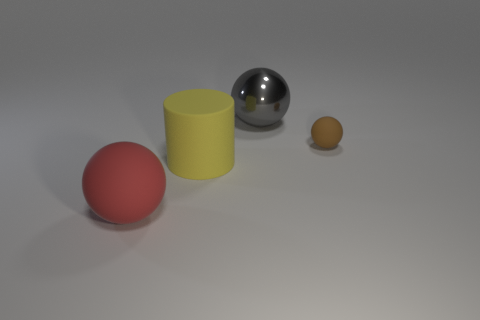Subtract all large spheres. How many spheres are left? 1 Add 3 yellow rubber cylinders. How many objects exist? 7 Subtract all yellow balls. Subtract all red cylinders. How many balls are left? 3 Subtract all small blue things. Subtract all rubber spheres. How many objects are left? 2 Add 1 large yellow matte cylinders. How many large yellow matte cylinders are left? 2 Add 2 big brown metal blocks. How many big brown metal blocks exist? 2 Subtract 0 purple cylinders. How many objects are left? 4 Subtract all spheres. How many objects are left? 1 